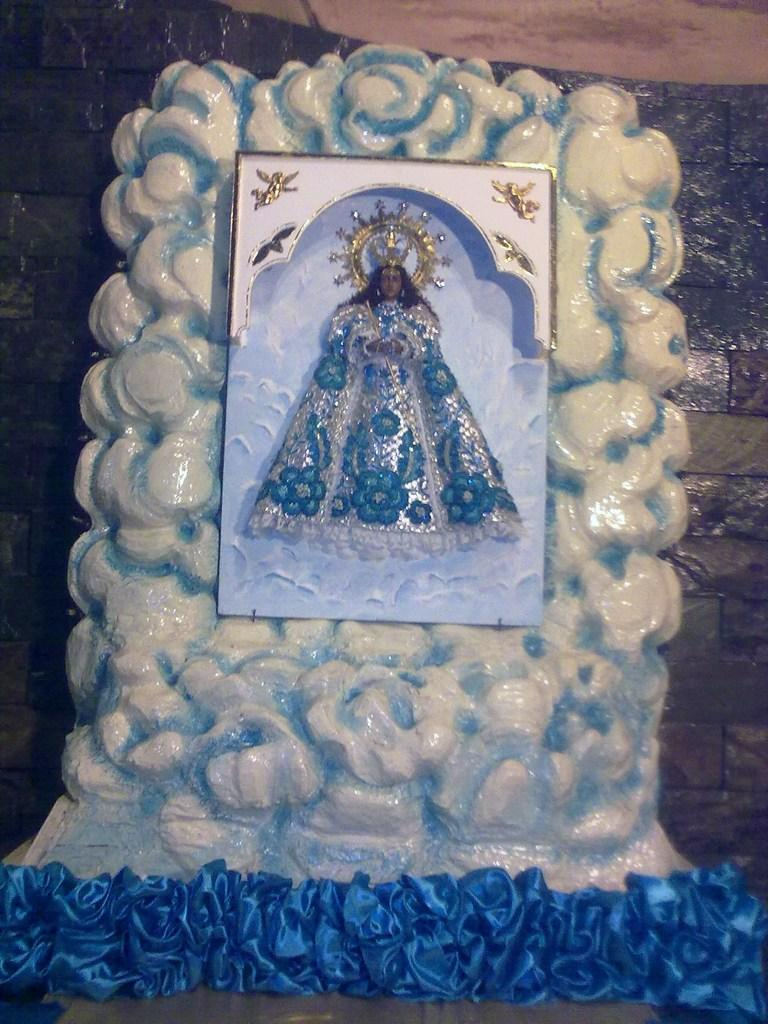What is the main subject in the image? There is a sculpture in the image. What material is the sculpture made of? The sculpture is made with stone. What type of notebook is being used by the sisters in the image? There are no sisters or notebooks present in the image; it features a sculpture made of stone. What type of brass instrument is being played by the sculpture in the image? There is no brass instrument present in the image; it features a sculpture made of stone. 